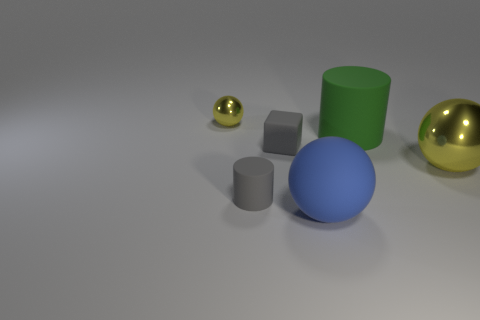What number of blue things are small rubber cylinders or big matte balls?
Keep it short and to the point. 1. What is the color of the matte thing that is on the right side of the big blue ball that is in front of the matte block?
Make the answer very short. Green. What is the material of the large object that is the same color as the small shiny ball?
Give a very brief answer. Metal. What color is the matte cylinder to the left of the green cylinder?
Offer a very short reply. Gray. There is a yellow metal sphere that is in front of the green cylinder; does it have the same size as the big green matte thing?
Provide a short and direct response. Yes. The cylinder that is the same color as the tiny rubber cube is what size?
Your response must be concise. Small. Are there any metal things that have the same size as the cube?
Give a very brief answer. Yes. There is a metallic object to the left of the big yellow metallic thing; does it have the same color as the rubber object behind the tiny block?
Provide a short and direct response. No. Are there any large cylinders of the same color as the large metal ball?
Provide a short and direct response. No. What number of other things are the same shape as the big yellow metallic thing?
Ensure brevity in your answer.  2. 